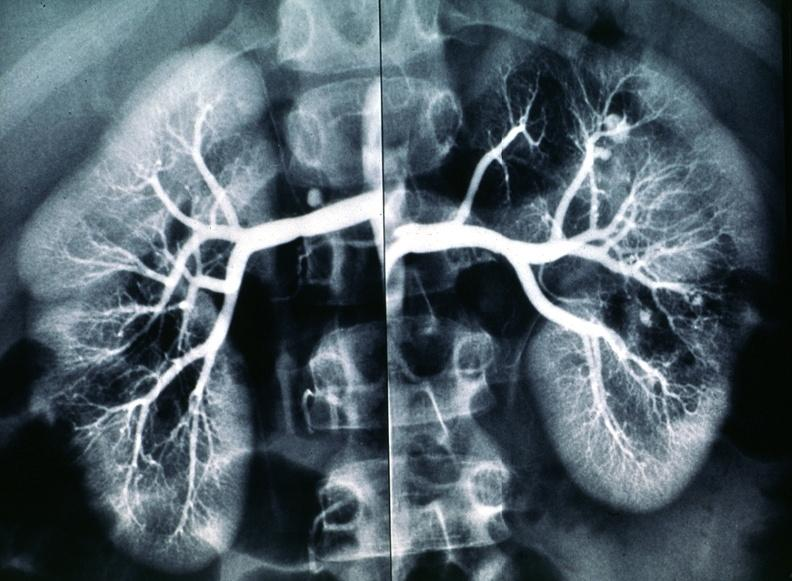does this image show polyarteritis nodosa, kidney arteriogram?
Answer the question using a single word or phrase. Yes 